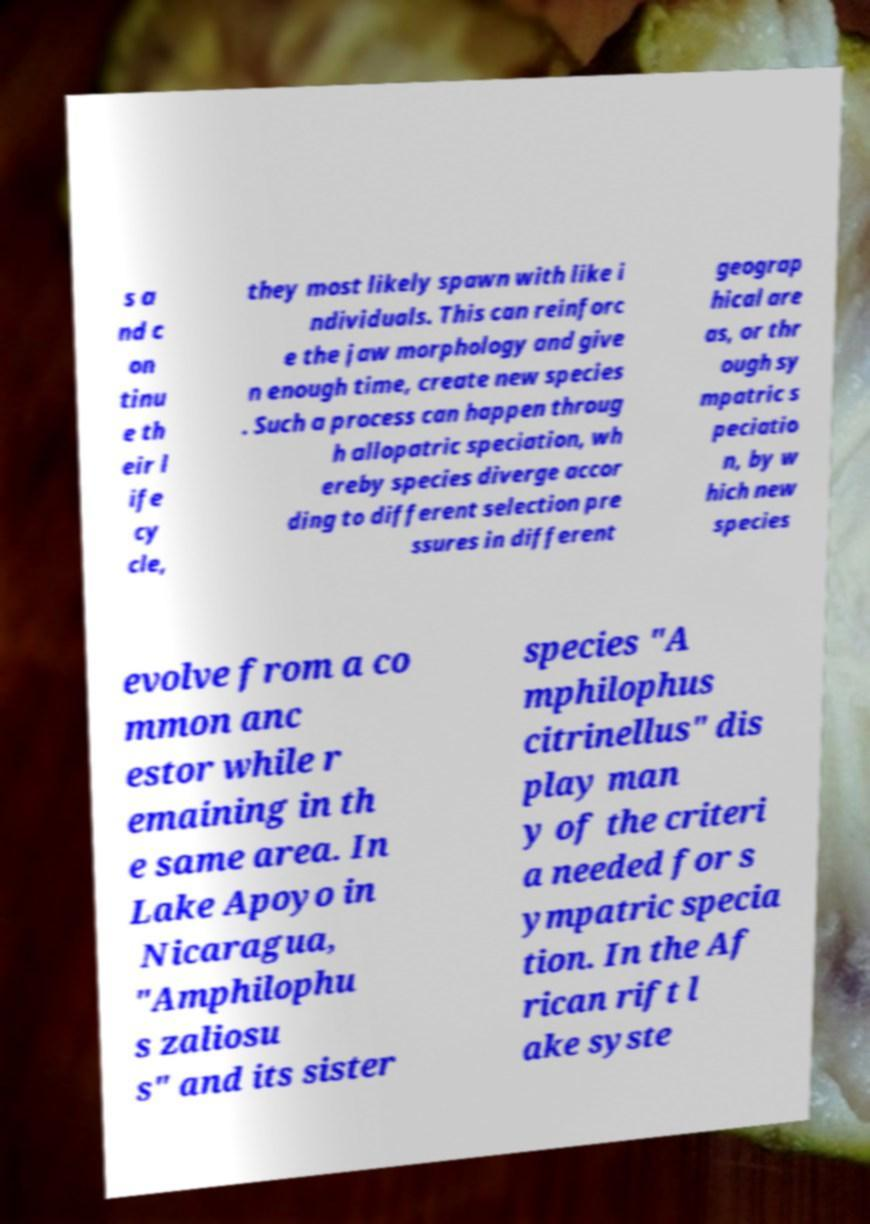Please identify and transcribe the text found in this image. s a nd c on tinu e th eir l ife cy cle, they most likely spawn with like i ndividuals. This can reinforc e the jaw morphology and give n enough time, create new species . Such a process can happen throug h allopatric speciation, wh ereby species diverge accor ding to different selection pre ssures in different geograp hical are as, or thr ough sy mpatric s peciatio n, by w hich new species evolve from a co mmon anc estor while r emaining in th e same area. In Lake Apoyo in Nicaragua, "Amphilophu s zaliosu s" and its sister species "A mphilophus citrinellus" dis play man y of the criteri a needed for s ympatric specia tion. In the Af rican rift l ake syste 